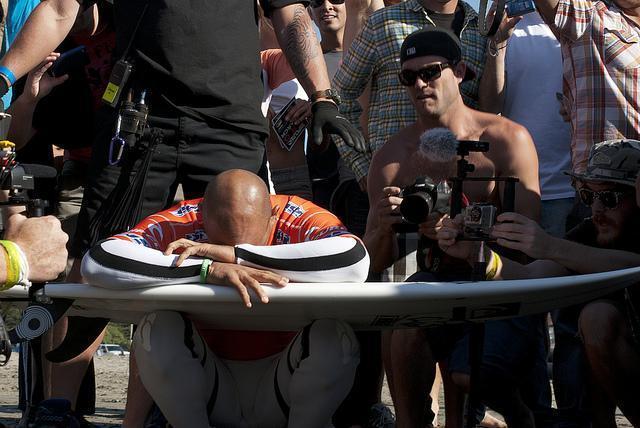How many people are there?
Give a very brief answer. 8. How many birds are going to fly there in the image?
Give a very brief answer. 0. 